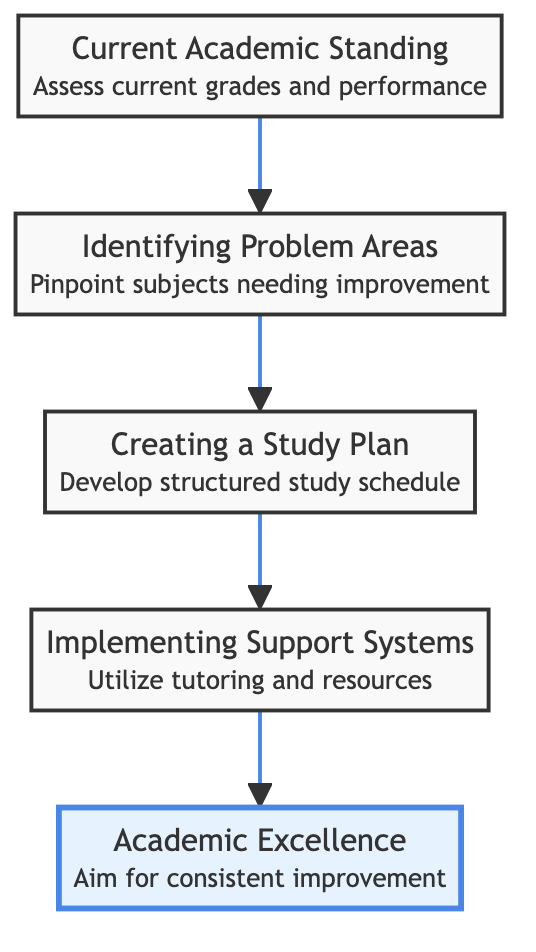What is the top node in the diagram? The diagram indicates that "Academic Excellence" is the foremost node at the top of the flow, representing the ultimate goal.
Answer: Academic Excellence How many nodes are present in the diagram? The diagram contains five main descriptive nodes: "Current Academic Standing," "Identifying Problem Areas," "Creating a Study Plan," "Implementing Support Systems," and "Academic Excellence."
Answer: Five What is the relationship between "Creating a Study Plan" and "Implementing Support Systems"? "Creating a Study Plan" is directly followed by "Implementing Support Systems" in the flow, indicating that a study plan leads to the need for support systems to enhance academic performance.
Answer: Sequential Which node precedes "Academic Excellence"? "Implementing Support Systems" is the node immediately before "Academic Excellence," highlighting that support must be in place to achieve academic excellence.
Answer: Implementing Support Systems What should be assessed to establish the "Current Academic Standing"? To assess the "Current Academic Standing," one should review current grades, class performance, and teacher feedback.
Answer: Grades, performance, teacher feedback What is the main objective of "Identifying Problem Areas"? The primary objective of "Identifying Problem Areas" is to engage with teachers and discuss with children to pinpoint subjects that need improvement.
Answer: Pinpoint subjects needing improvement How does "Creating a Study Plan" relate to "Identifying Problem Areas"? "Creating a Study Plan" follows from "Identifying Problem Areas," suggesting that understanding problem areas is essential for effectively structuring a study plan.
Answer: It is based on identified problem areas What is the focus of the final outcome node, "Academic Excellence"? The focus of "Academic Excellence" includes consistent improvement and regular progress reviews to maintain high academic standards.
Answer: Consistent improvement Which resource is suggested under "Implementing Support Systems"? The diagram suggests utilizing tutoring as a resource under "Implementing Support Systems," among other support options.
Answer: Tutoring 